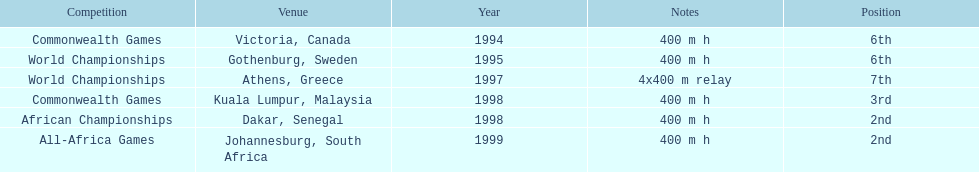What was the duration of the relay in the 1997 world championships where ken harden participated? 4x400 m relay. 